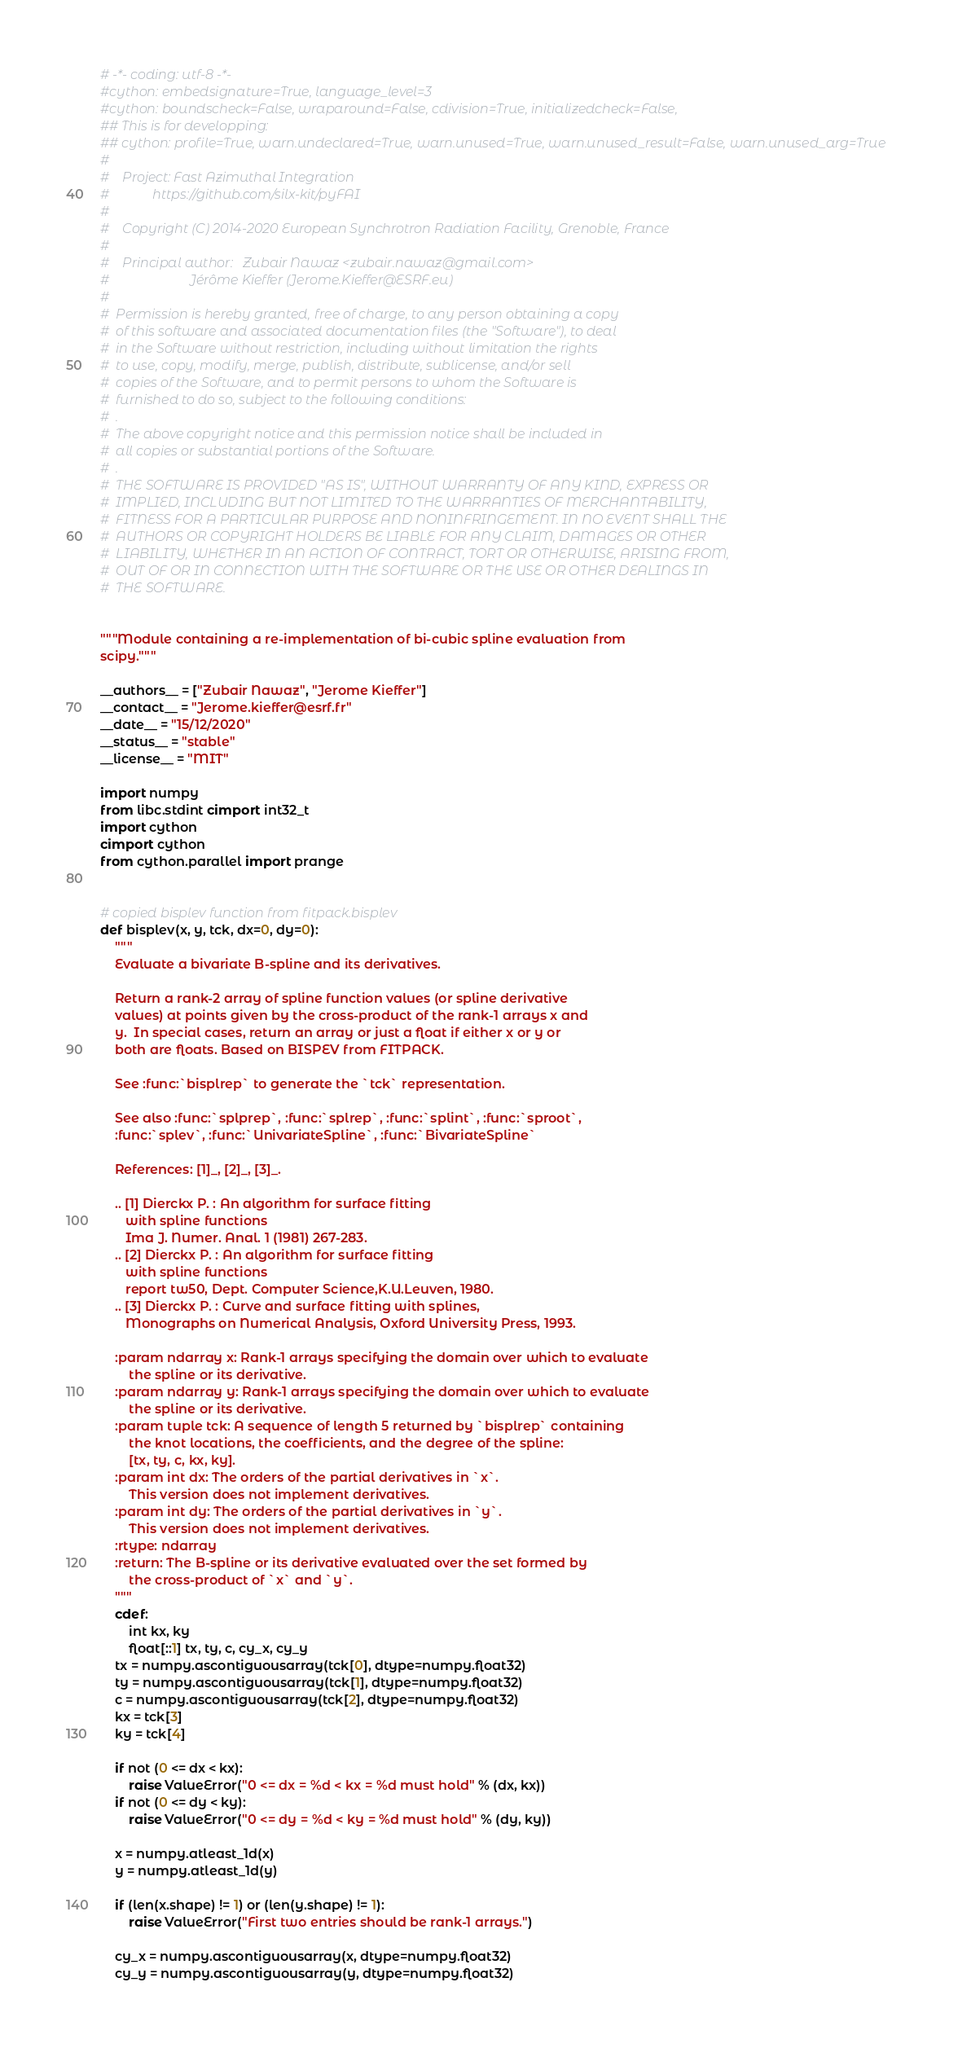Convert code to text. <code><loc_0><loc_0><loc_500><loc_500><_Cython_># -*- coding: utf-8 -*-
#cython: embedsignature=True, language_level=3
#cython: boundscheck=False, wraparound=False, cdivision=True, initializedcheck=False,
## This is for developping:
## cython: profile=True, warn.undeclared=True, warn.unused=True, warn.unused_result=False, warn.unused_arg=True
#
#    Project: Fast Azimuthal Integration
#             https://github.com/silx-kit/pyFAI
#
#    Copyright (C) 2014-2020 European Synchrotron Radiation Facility, Grenoble, France
#
#    Principal author:   Zubair Nawaz <zubair.nawaz@gmail.com>
#                        Jérôme Kieffer (Jerome.Kieffer@ESRF.eu)
#
#  Permission is hereby granted, free of charge, to any person obtaining a copy
#  of this software and associated documentation files (the "Software"), to deal
#  in the Software without restriction, including without limitation the rights
#  to use, copy, modify, merge, publish, distribute, sublicense, and/or sell
#  copies of the Software, and to permit persons to whom the Software is
#  furnished to do so, subject to the following conditions:
#  .
#  The above copyright notice and this permission notice shall be included in
#  all copies or substantial portions of the Software.
#  .
#  THE SOFTWARE IS PROVIDED "AS IS", WITHOUT WARRANTY OF ANY KIND, EXPRESS OR
#  IMPLIED, INCLUDING BUT NOT LIMITED TO THE WARRANTIES OF MERCHANTABILITY,
#  FITNESS FOR A PARTICULAR PURPOSE AND NONINFRINGEMENT. IN NO EVENT SHALL THE
#  AUTHORS OR COPYRIGHT HOLDERS BE LIABLE FOR ANY CLAIM, DAMAGES OR OTHER
#  LIABILITY, WHETHER IN AN ACTION OF CONTRACT, TORT OR OTHERWISE, ARISING FROM,
#  OUT OF OR IN CONNECTION WITH THE SOFTWARE OR THE USE OR OTHER DEALINGS IN
#  THE SOFTWARE.


"""Module containing a re-implementation of bi-cubic spline evaluation from
scipy."""

__authors__ = ["Zubair Nawaz", "Jerome Kieffer"]
__contact__ = "Jerome.kieffer@esrf.fr"
__date__ = "15/12/2020"
__status__ = "stable"
__license__ = "MIT"

import numpy
from libc.stdint cimport int32_t
import cython
cimport cython
from cython.parallel import prange


# copied bisplev function from fitpack.bisplev
def bisplev(x, y, tck, dx=0, dy=0):
    """
    Evaluate a bivariate B-spline and its derivatives.

    Return a rank-2 array of spline function values (or spline derivative
    values) at points given by the cross-product of the rank-1 arrays x and
    y.  In special cases, return an array or just a float if either x or y or
    both are floats. Based on BISPEV from FITPACK.

    See :func:`bisplrep` to generate the `tck` representation.

    See also :func:`splprep`, :func:`splrep`, :func:`splint`, :func:`sproot`,
    :func:`splev`, :func:`UnivariateSpline`, :func:`BivariateSpline`

    References: [1]_, [2]_, [3]_.

    .. [1] Dierckx P. : An algorithm for surface fitting
       with spline functions
       Ima J. Numer. Anal. 1 (1981) 267-283.
    .. [2] Dierckx P. : An algorithm for surface fitting
       with spline functions
       report tw50, Dept. Computer Science,K.U.Leuven, 1980.
    .. [3] Dierckx P. : Curve and surface fitting with splines,
       Monographs on Numerical Analysis, Oxford University Press, 1993.

    :param ndarray x: Rank-1 arrays specifying the domain over which to evaluate
        the spline or its derivative.
    :param ndarray y: Rank-1 arrays specifying the domain over which to evaluate
        the spline or its derivative.
    :param tuple tck: A sequence of length 5 returned by `bisplrep` containing
        the knot locations, the coefficients, and the degree of the spline:
        [tx, ty, c, kx, ky].
    :param int dx: The orders of the partial derivatives in `x`.
        This version does not implement derivatives.
    :param int dy: The orders of the partial derivatives in `y`.
        This version does not implement derivatives.
    :rtype: ndarray
    :return: The B-spline or its derivative evaluated over the set formed by
        the cross-product of `x` and `y`.
    """
    cdef:
        int kx, ky
        float[::1] tx, ty, c, cy_x, cy_y
    tx = numpy.ascontiguousarray(tck[0], dtype=numpy.float32)
    ty = numpy.ascontiguousarray(tck[1], dtype=numpy.float32)
    c = numpy.ascontiguousarray(tck[2], dtype=numpy.float32)
    kx = tck[3]
    ky = tck[4]

    if not (0 <= dx < kx):
        raise ValueError("0 <= dx = %d < kx = %d must hold" % (dx, kx))
    if not (0 <= dy < ky):
        raise ValueError("0 <= dy = %d < ky = %d must hold" % (dy, ky))

    x = numpy.atleast_1d(x)
    y = numpy.atleast_1d(y)

    if (len(x.shape) != 1) or (len(y.shape) != 1):
        raise ValueError("First two entries should be rank-1 arrays.")

    cy_x = numpy.ascontiguousarray(x, dtype=numpy.float32)
    cy_y = numpy.ascontiguousarray(y, dtype=numpy.float32)
</code> 